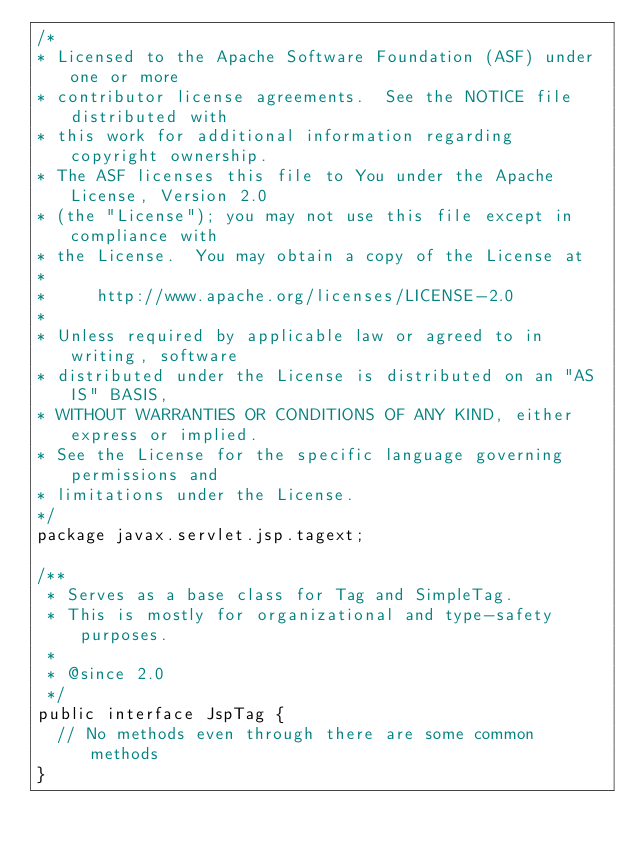Convert code to text. <code><loc_0><loc_0><loc_500><loc_500><_Java_>/*
* Licensed to the Apache Software Foundation (ASF) under one or more
* contributor license agreements.  See the NOTICE file distributed with
* this work for additional information regarding copyright ownership.
* The ASF licenses this file to You under the Apache License, Version 2.0
* (the "License"); you may not use this file except in compliance with
* the License.  You may obtain a copy of the License at
*
*     http://www.apache.org/licenses/LICENSE-2.0
*
* Unless required by applicable law or agreed to in writing, software
* distributed under the License is distributed on an "AS IS" BASIS,
* WITHOUT WARRANTIES OR CONDITIONS OF ANY KIND, either express or implied.
* See the License for the specific language governing permissions and
* limitations under the License.
*/
package javax.servlet.jsp.tagext;

/**
 * Serves as a base class for Tag and SimpleTag.
 * This is mostly for organizational and type-safety purposes.
 *
 * @since 2.0
 */
public interface JspTag {
	// No methods even through there are some common methods
}
</code> 